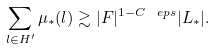Convert formula to latex. <formula><loc_0><loc_0><loc_500><loc_500>\sum _ { l \in H ^ { \prime } } \mu _ { * } ( l ) \gtrsim | F | ^ { 1 - C \ e p s } | L _ { * } | .</formula> 